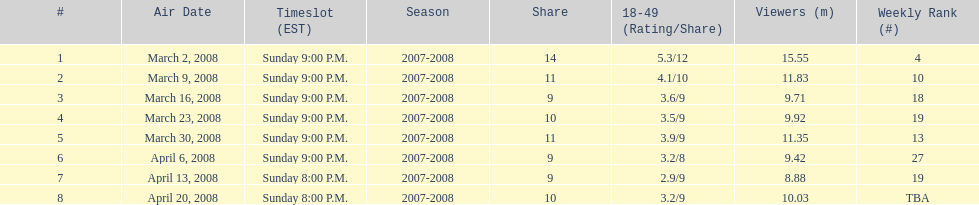Which show had the highest rating? 1. 